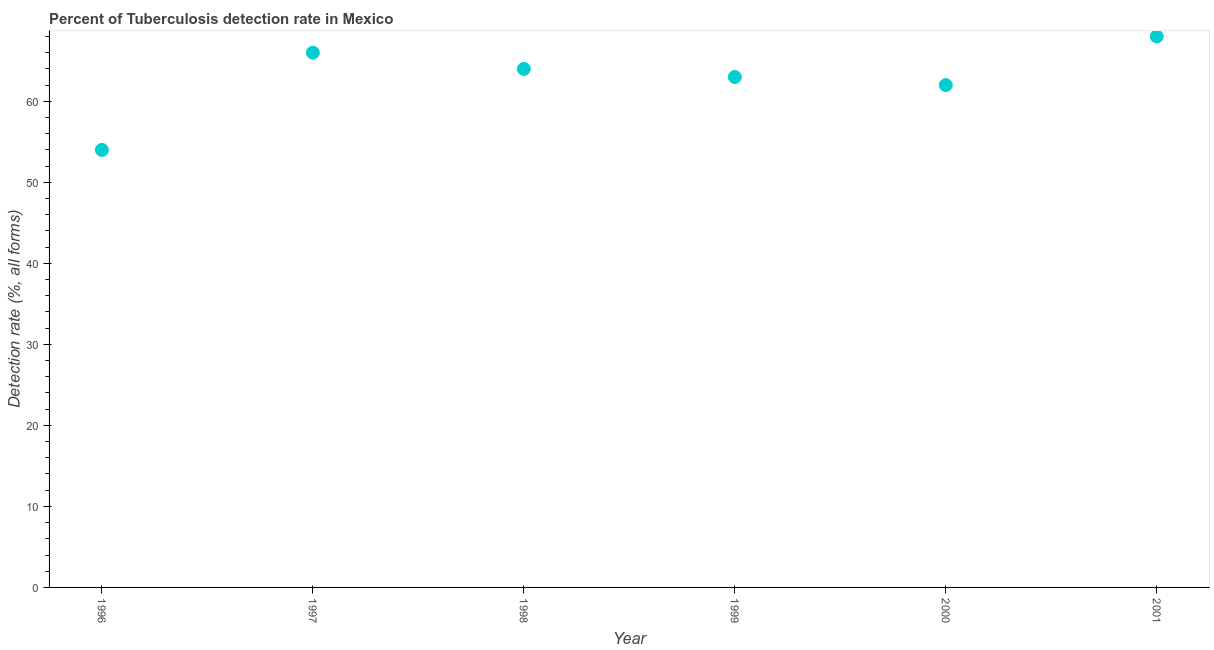What is the detection rate of tuberculosis in 2000?
Offer a terse response. 62. Across all years, what is the maximum detection rate of tuberculosis?
Ensure brevity in your answer.  68. Across all years, what is the minimum detection rate of tuberculosis?
Your answer should be compact. 54. In which year was the detection rate of tuberculosis minimum?
Keep it short and to the point. 1996. What is the sum of the detection rate of tuberculosis?
Offer a terse response. 377. What is the difference between the detection rate of tuberculosis in 1996 and 2001?
Ensure brevity in your answer.  -14. What is the average detection rate of tuberculosis per year?
Your response must be concise. 62.83. What is the median detection rate of tuberculosis?
Provide a succinct answer. 63.5. What is the ratio of the detection rate of tuberculosis in 1997 to that in 1999?
Give a very brief answer. 1.05. Is the detection rate of tuberculosis in 1997 less than that in 2000?
Offer a terse response. No. Is the difference between the detection rate of tuberculosis in 1998 and 2000 greater than the difference between any two years?
Provide a succinct answer. No. What is the difference between the highest and the second highest detection rate of tuberculosis?
Make the answer very short. 2. Is the sum of the detection rate of tuberculosis in 1996 and 2000 greater than the maximum detection rate of tuberculosis across all years?
Keep it short and to the point. Yes. What is the difference between the highest and the lowest detection rate of tuberculosis?
Provide a succinct answer. 14. How many dotlines are there?
Offer a very short reply. 1. What is the difference between two consecutive major ticks on the Y-axis?
Keep it short and to the point. 10. Are the values on the major ticks of Y-axis written in scientific E-notation?
Your answer should be compact. No. What is the title of the graph?
Make the answer very short. Percent of Tuberculosis detection rate in Mexico. What is the label or title of the X-axis?
Ensure brevity in your answer.  Year. What is the label or title of the Y-axis?
Give a very brief answer. Detection rate (%, all forms). What is the Detection rate (%, all forms) in 1997?
Offer a terse response. 66. What is the Detection rate (%, all forms) in 1998?
Provide a succinct answer. 64. What is the Detection rate (%, all forms) in 1999?
Ensure brevity in your answer.  63. What is the Detection rate (%, all forms) in 2001?
Ensure brevity in your answer.  68. What is the difference between the Detection rate (%, all forms) in 1996 and 1998?
Your answer should be compact. -10. What is the difference between the Detection rate (%, all forms) in 1996 and 1999?
Give a very brief answer. -9. What is the difference between the Detection rate (%, all forms) in 1996 and 2000?
Your answer should be compact. -8. What is the difference between the Detection rate (%, all forms) in 1997 and 1999?
Offer a terse response. 3. What is the difference between the Detection rate (%, all forms) in 1997 and 2000?
Ensure brevity in your answer.  4. What is the difference between the Detection rate (%, all forms) in 1998 and 1999?
Ensure brevity in your answer.  1. What is the difference between the Detection rate (%, all forms) in 1999 and 2000?
Your response must be concise. 1. What is the ratio of the Detection rate (%, all forms) in 1996 to that in 1997?
Provide a short and direct response. 0.82. What is the ratio of the Detection rate (%, all forms) in 1996 to that in 1998?
Give a very brief answer. 0.84. What is the ratio of the Detection rate (%, all forms) in 1996 to that in 1999?
Provide a succinct answer. 0.86. What is the ratio of the Detection rate (%, all forms) in 1996 to that in 2000?
Ensure brevity in your answer.  0.87. What is the ratio of the Detection rate (%, all forms) in 1996 to that in 2001?
Make the answer very short. 0.79. What is the ratio of the Detection rate (%, all forms) in 1997 to that in 1998?
Offer a very short reply. 1.03. What is the ratio of the Detection rate (%, all forms) in 1997 to that in 1999?
Your response must be concise. 1.05. What is the ratio of the Detection rate (%, all forms) in 1997 to that in 2000?
Your response must be concise. 1.06. What is the ratio of the Detection rate (%, all forms) in 1997 to that in 2001?
Provide a short and direct response. 0.97. What is the ratio of the Detection rate (%, all forms) in 1998 to that in 1999?
Provide a short and direct response. 1.02. What is the ratio of the Detection rate (%, all forms) in 1998 to that in 2000?
Your answer should be compact. 1.03. What is the ratio of the Detection rate (%, all forms) in 1998 to that in 2001?
Give a very brief answer. 0.94. What is the ratio of the Detection rate (%, all forms) in 1999 to that in 2001?
Keep it short and to the point. 0.93. What is the ratio of the Detection rate (%, all forms) in 2000 to that in 2001?
Give a very brief answer. 0.91. 